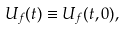Convert formula to latex. <formula><loc_0><loc_0><loc_500><loc_500>U _ { f } ( t ) \equiv U _ { f } ( t , 0 ) ,</formula> 